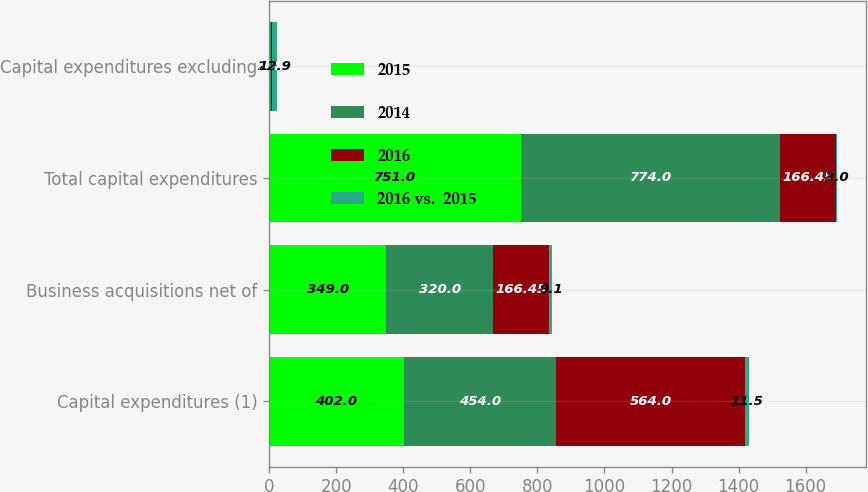Convert chart. <chart><loc_0><loc_0><loc_500><loc_500><stacked_bar_chart><ecel><fcel>Capital expenditures (1)<fcel>Business acquisitions net of<fcel>Total capital expenditures<fcel>Capital expenditures excluding<nl><fcel>2015<fcel>402<fcel>349<fcel>751<fcel>2.7<nl><fcel>2014<fcel>454<fcel>320<fcel>774<fcel>3.1<nl><fcel>2016<fcel>564<fcel>166.45<fcel>166.45<fcel>3.8<nl><fcel>2016 vs.  2015<fcel>11.5<fcel>9.1<fcel>3<fcel>12.9<nl></chart> 